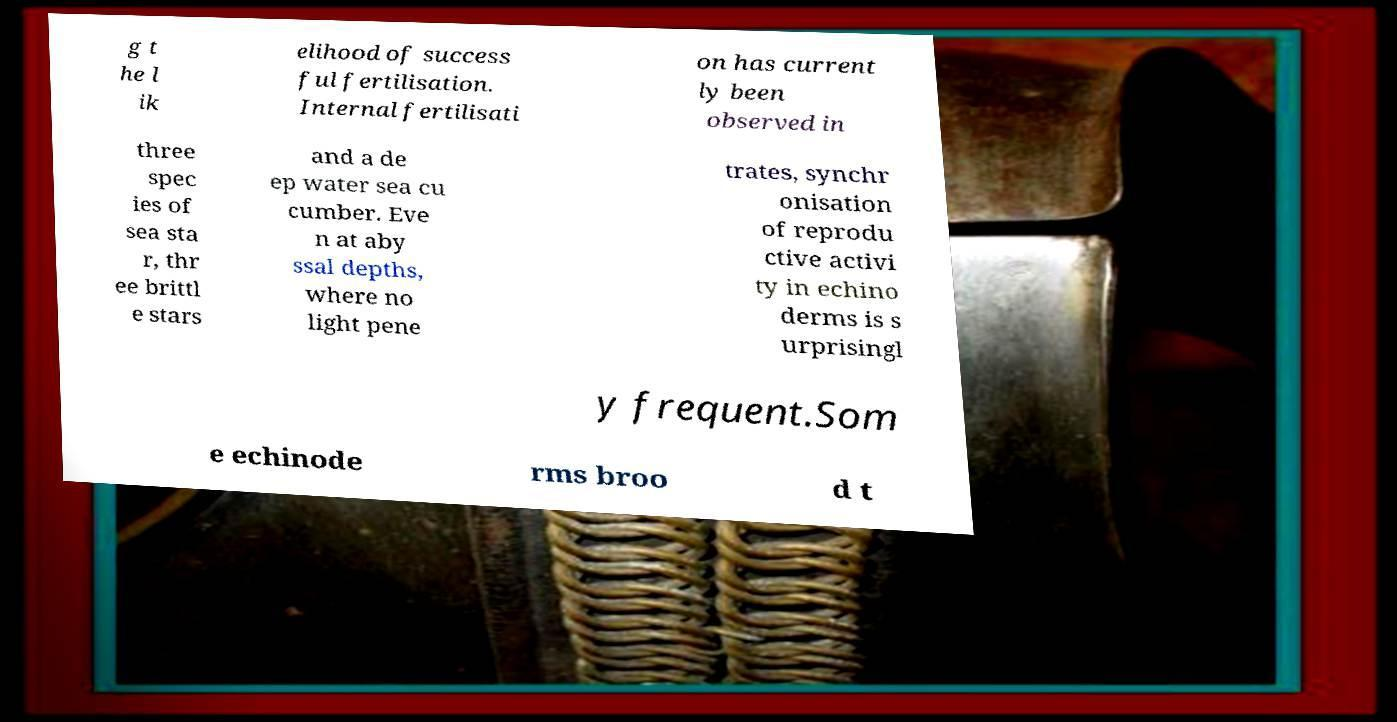Can you accurately transcribe the text from the provided image for me? g t he l ik elihood of success ful fertilisation. Internal fertilisati on has current ly been observed in three spec ies of sea sta r, thr ee brittl e stars and a de ep water sea cu cumber. Eve n at aby ssal depths, where no light pene trates, synchr onisation of reprodu ctive activi ty in echino derms is s urprisingl y frequent.Som e echinode rms broo d t 